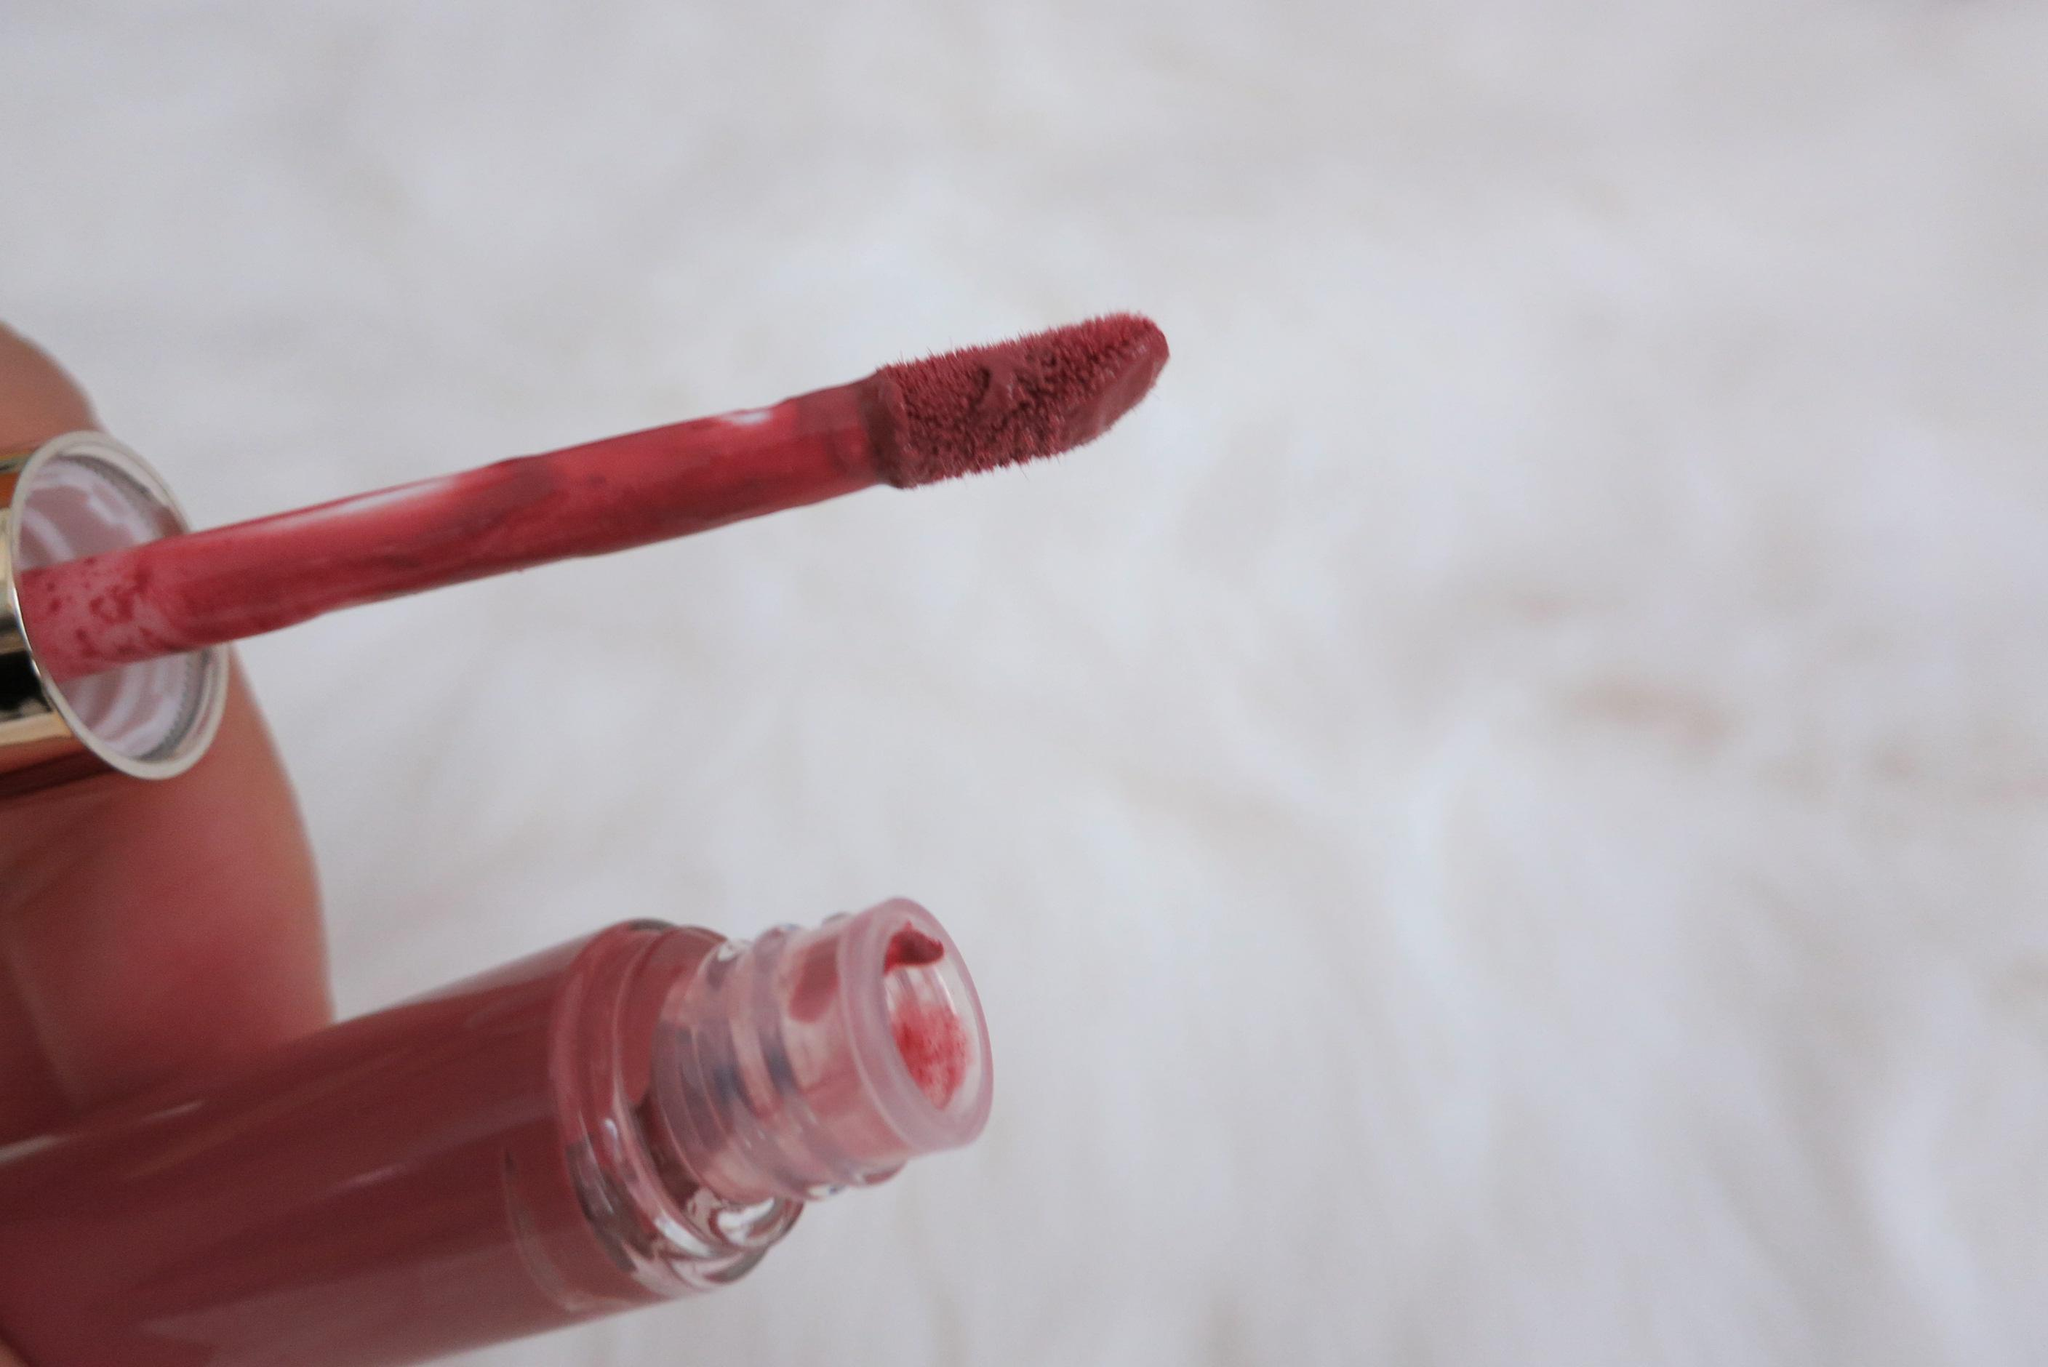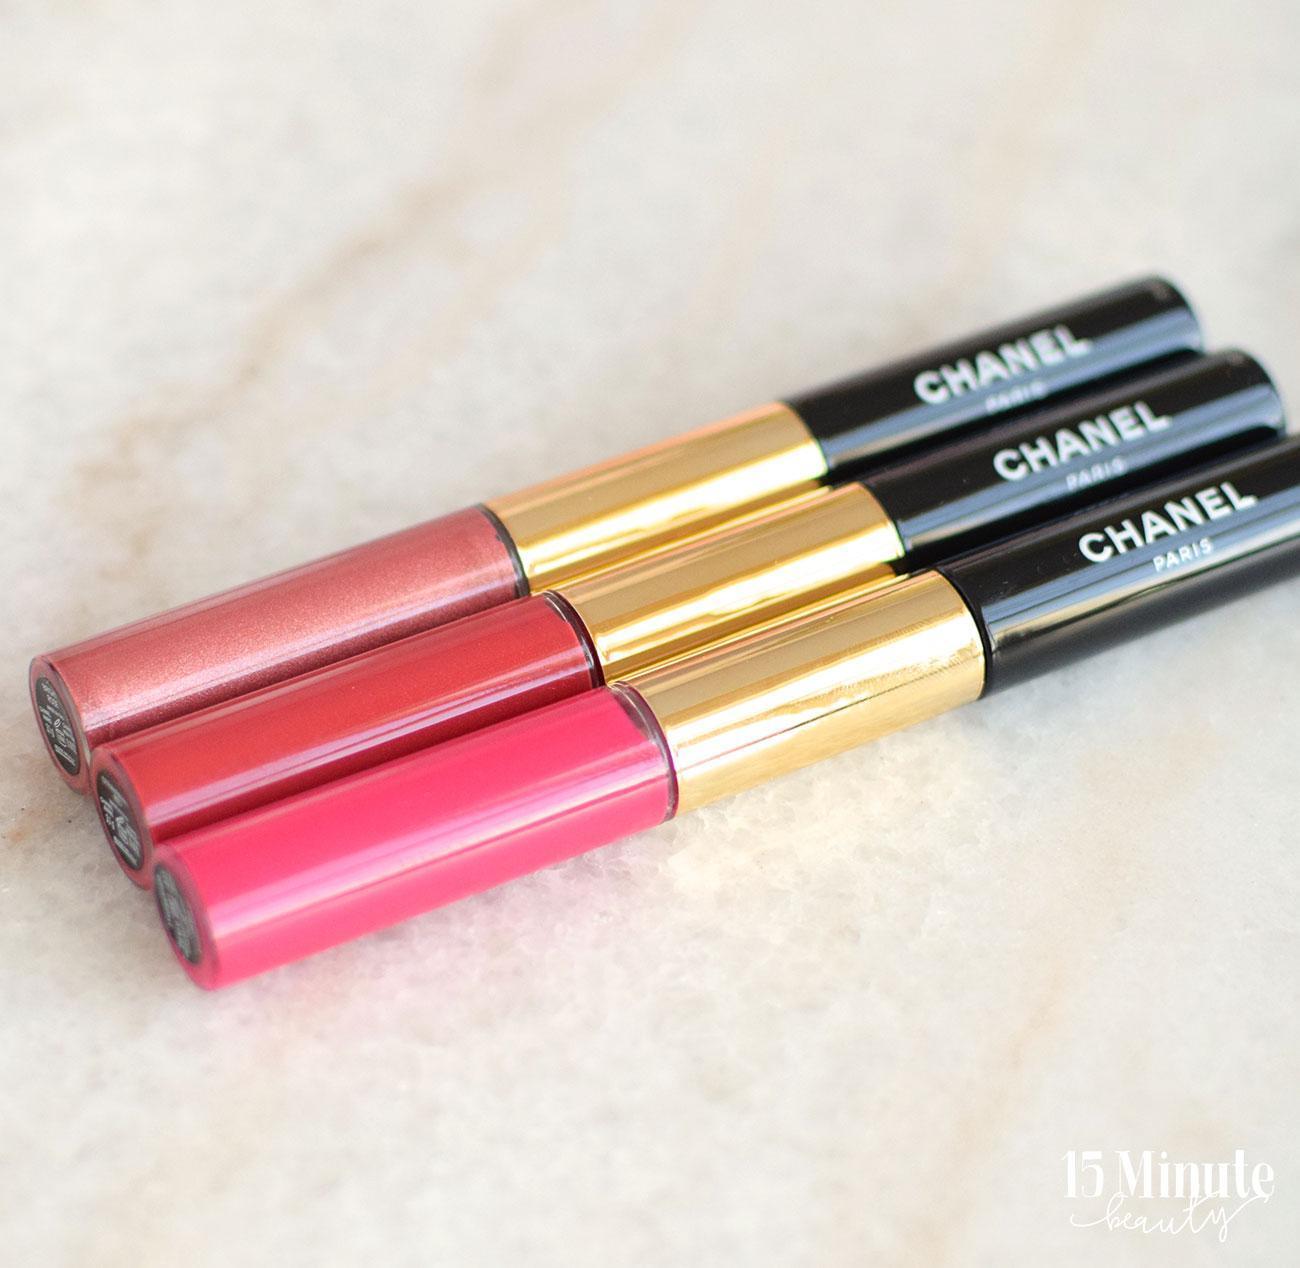The first image is the image on the left, the second image is the image on the right. Given the left and right images, does the statement "there is a black bottle with an open lip gloss wand with a gold handle" hold true? Answer yes or no. No. The first image is the image on the left, the second image is the image on the right. For the images displayed, is the sentence "The left image contains an uncapped lipstick wand, and the right image includes at least one capped lip makeup." factually correct? Answer yes or no. Yes. 